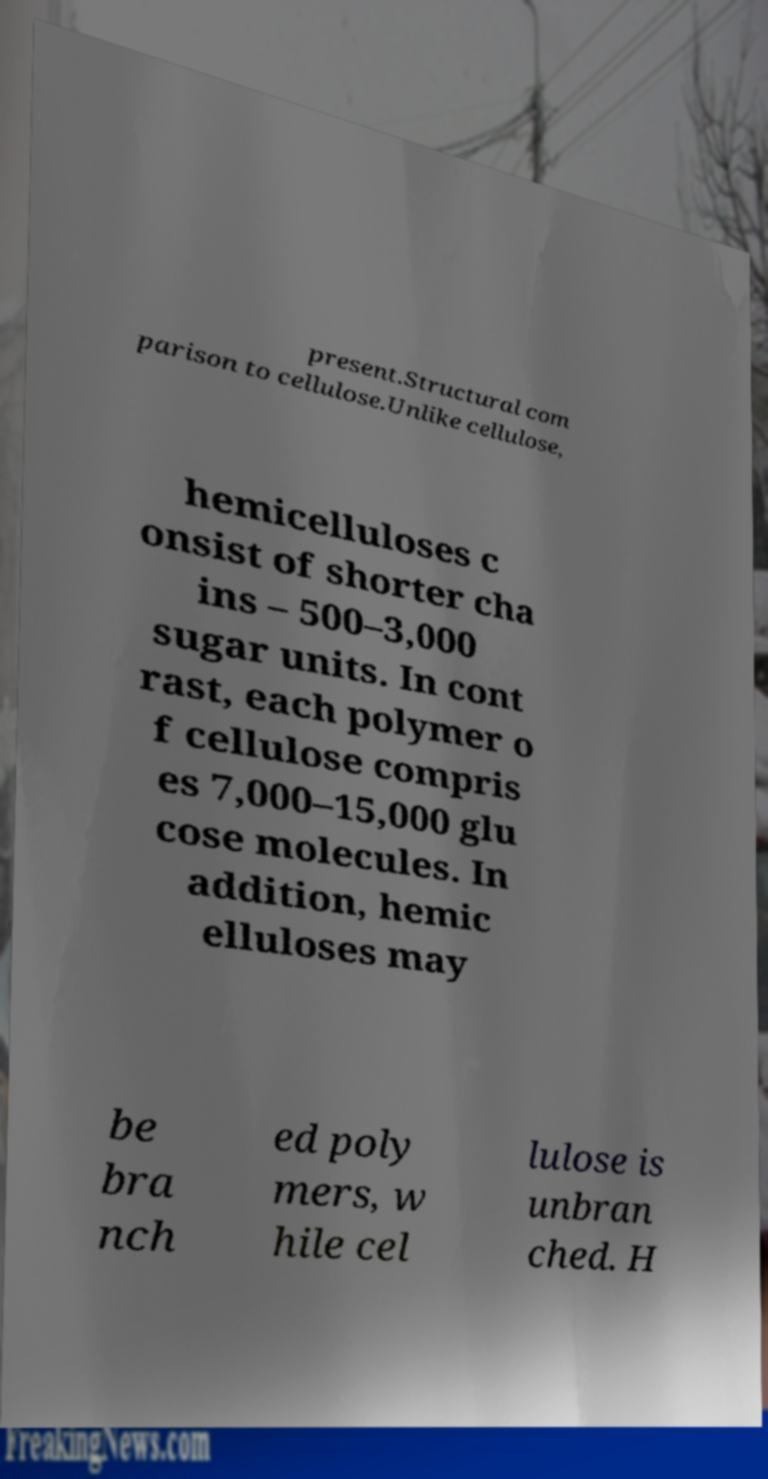There's text embedded in this image that I need extracted. Can you transcribe it verbatim? present.Structural com parison to cellulose.Unlike cellulose, hemicelluloses c onsist of shorter cha ins – 500–3,000 sugar units. In cont rast, each polymer o f cellulose compris es 7,000–15,000 glu cose molecules. In addition, hemic elluloses may be bra nch ed poly mers, w hile cel lulose is unbran ched. H 